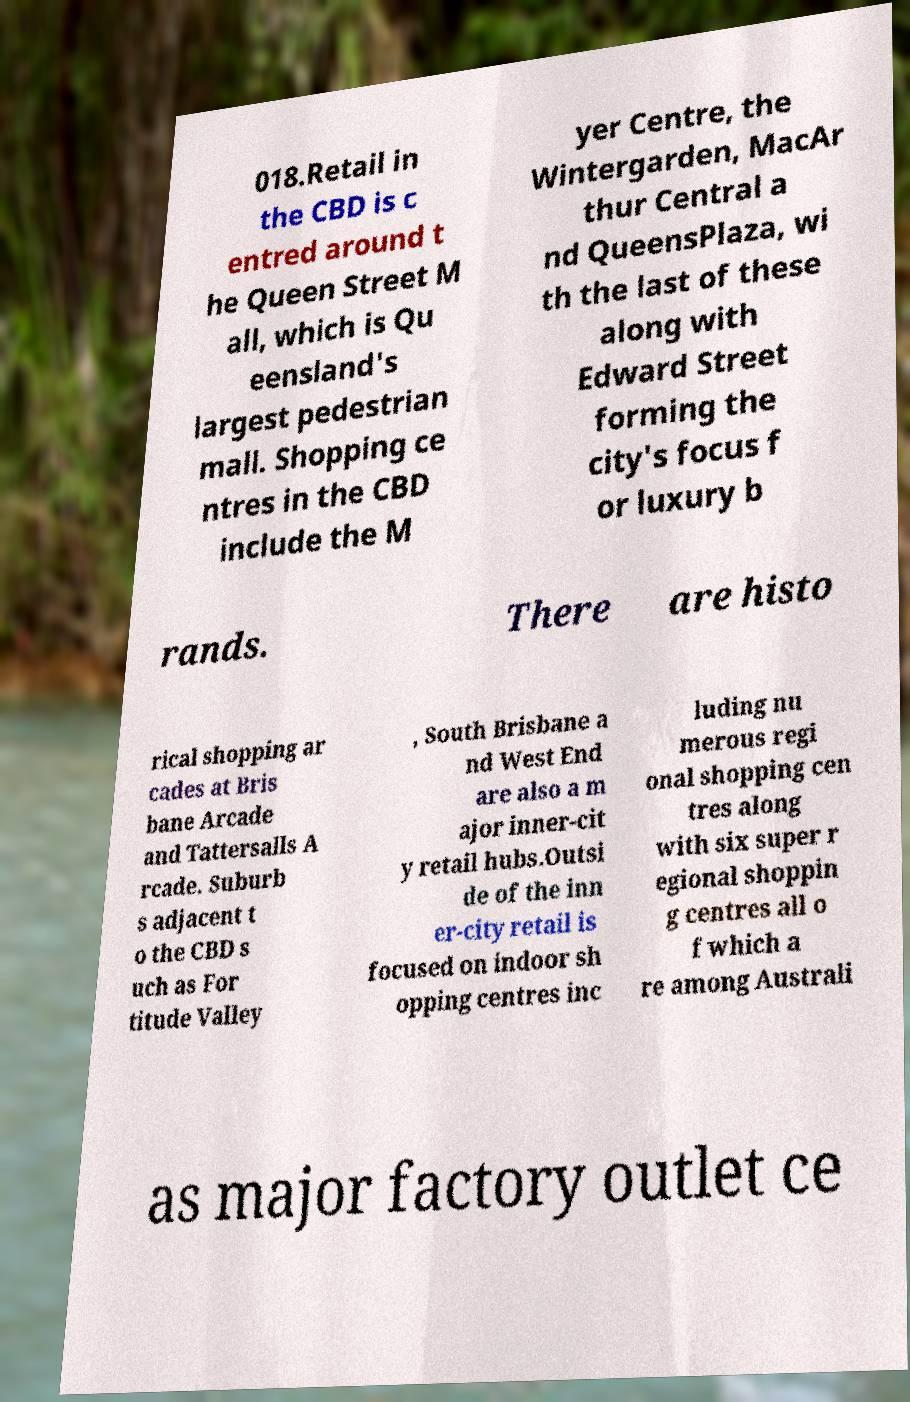Please identify and transcribe the text found in this image. 018.Retail in the CBD is c entred around t he Queen Street M all, which is Qu eensland's largest pedestrian mall. Shopping ce ntres in the CBD include the M yer Centre, the Wintergarden, MacAr thur Central a nd QueensPlaza, wi th the last of these along with Edward Street forming the city's focus f or luxury b rands. There are histo rical shopping ar cades at Bris bane Arcade and Tattersalls A rcade. Suburb s adjacent t o the CBD s uch as For titude Valley , South Brisbane a nd West End are also a m ajor inner-cit y retail hubs.Outsi de of the inn er-city retail is focused on indoor sh opping centres inc luding nu merous regi onal shopping cen tres along with six super r egional shoppin g centres all o f which a re among Australi as major factory outlet ce 